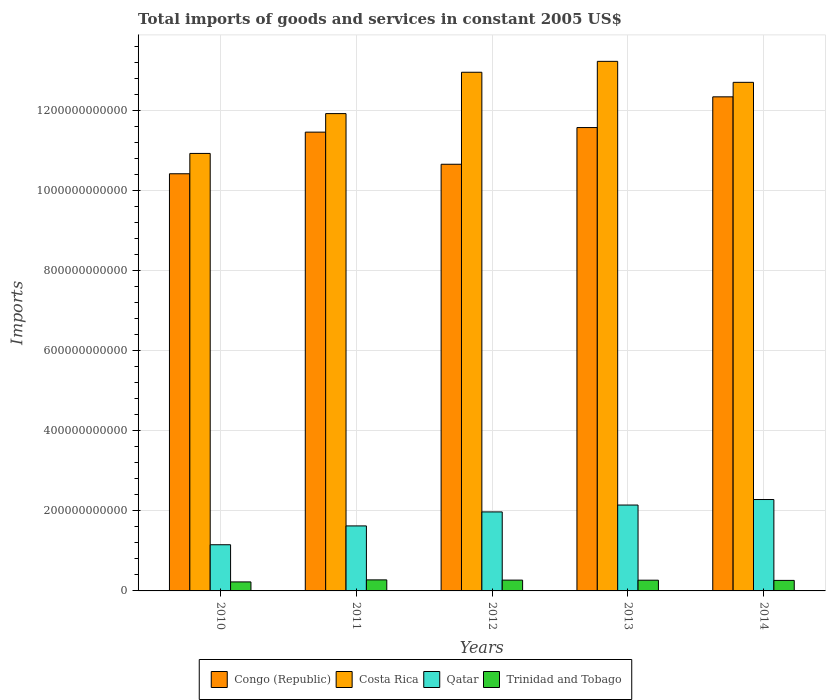How many different coloured bars are there?
Make the answer very short. 4. Are the number of bars per tick equal to the number of legend labels?
Ensure brevity in your answer.  Yes. What is the label of the 5th group of bars from the left?
Ensure brevity in your answer.  2014. What is the total imports of goods and services in Costa Rica in 2011?
Provide a succinct answer. 1.19e+12. Across all years, what is the maximum total imports of goods and services in Qatar?
Offer a terse response. 2.28e+11. Across all years, what is the minimum total imports of goods and services in Congo (Republic)?
Your answer should be compact. 1.04e+12. What is the total total imports of goods and services in Qatar in the graph?
Ensure brevity in your answer.  9.18e+11. What is the difference between the total imports of goods and services in Costa Rica in 2011 and that in 2013?
Give a very brief answer. -1.31e+11. What is the difference between the total imports of goods and services in Trinidad and Tobago in 2010 and the total imports of goods and services in Qatar in 2013?
Your response must be concise. -1.92e+11. What is the average total imports of goods and services in Trinidad and Tobago per year?
Offer a terse response. 2.60e+1. In the year 2014, what is the difference between the total imports of goods and services in Qatar and total imports of goods and services in Costa Rica?
Provide a short and direct response. -1.04e+12. In how many years, is the total imports of goods and services in Qatar greater than 80000000000 US$?
Offer a terse response. 5. What is the ratio of the total imports of goods and services in Congo (Republic) in 2010 to that in 2011?
Offer a very short reply. 0.91. What is the difference between the highest and the second highest total imports of goods and services in Congo (Republic)?
Your answer should be very brief. 7.68e+1. What is the difference between the highest and the lowest total imports of goods and services in Costa Rica?
Your answer should be compact. 2.30e+11. In how many years, is the total imports of goods and services in Costa Rica greater than the average total imports of goods and services in Costa Rica taken over all years?
Keep it short and to the point. 3. Is the sum of the total imports of goods and services in Trinidad and Tobago in 2010 and 2011 greater than the maximum total imports of goods and services in Congo (Republic) across all years?
Provide a short and direct response. No. Is it the case that in every year, the sum of the total imports of goods and services in Qatar and total imports of goods and services in Congo (Republic) is greater than the sum of total imports of goods and services in Costa Rica and total imports of goods and services in Trinidad and Tobago?
Ensure brevity in your answer.  No. What does the 1st bar from the left in 2010 represents?
Make the answer very short. Congo (Republic). What does the 3rd bar from the right in 2012 represents?
Provide a succinct answer. Costa Rica. Is it the case that in every year, the sum of the total imports of goods and services in Congo (Republic) and total imports of goods and services in Qatar is greater than the total imports of goods and services in Costa Rica?
Offer a terse response. No. How many years are there in the graph?
Your answer should be very brief. 5. What is the difference between two consecutive major ticks on the Y-axis?
Offer a very short reply. 2.00e+11. Are the values on the major ticks of Y-axis written in scientific E-notation?
Your answer should be very brief. No. Does the graph contain grids?
Your response must be concise. Yes. Where does the legend appear in the graph?
Offer a terse response. Bottom center. What is the title of the graph?
Your answer should be very brief. Total imports of goods and services in constant 2005 US$. Does "European Union" appear as one of the legend labels in the graph?
Your answer should be very brief. No. What is the label or title of the X-axis?
Provide a short and direct response. Years. What is the label or title of the Y-axis?
Make the answer very short. Imports. What is the Imports of Congo (Republic) in 2010?
Your answer should be compact. 1.04e+12. What is the Imports in Costa Rica in 2010?
Provide a succinct answer. 1.09e+12. What is the Imports in Qatar in 2010?
Offer a terse response. 1.15e+11. What is the Imports in Trinidad and Tobago in 2010?
Your answer should be very brief. 2.25e+1. What is the Imports in Congo (Republic) in 2011?
Provide a succinct answer. 1.15e+12. What is the Imports of Costa Rica in 2011?
Keep it short and to the point. 1.19e+12. What is the Imports of Qatar in 2011?
Your answer should be compact. 1.62e+11. What is the Imports of Trinidad and Tobago in 2011?
Your answer should be very brief. 2.76e+1. What is the Imports of Congo (Republic) in 2012?
Your answer should be compact. 1.07e+12. What is the Imports of Costa Rica in 2012?
Make the answer very short. 1.30e+12. What is the Imports of Qatar in 2012?
Provide a short and direct response. 1.97e+11. What is the Imports in Trinidad and Tobago in 2012?
Ensure brevity in your answer.  2.70e+1. What is the Imports in Congo (Republic) in 2013?
Your answer should be very brief. 1.16e+12. What is the Imports in Costa Rica in 2013?
Your response must be concise. 1.32e+12. What is the Imports in Qatar in 2013?
Provide a succinct answer. 2.15e+11. What is the Imports in Trinidad and Tobago in 2013?
Your response must be concise. 2.68e+1. What is the Imports in Congo (Republic) in 2014?
Offer a terse response. 1.23e+12. What is the Imports in Costa Rica in 2014?
Make the answer very short. 1.27e+12. What is the Imports in Qatar in 2014?
Keep it short and to the point. 2.28e+11. What is the Imports in Trinidad and Tobago in 2014?
Offer a very short reply. 2.63e+1. Across all years, what is the maximum Imports of Congo (Republic)?
Offer a terse response. 1.23e+12. Across all years, what is the maximum Imports in Costa Rica?
Offer a terse response. 1.32e+12. Across all years, what is the maximum Imports in Qatar?
Your response must be concise. 2.28e+11. Across all years, what is the maximum Imports in Trinidad and Tobago?
Offer a very short reply. 2.76e+1. Across all years, what is the minimum Imports of Congo (Republic)?
Give a very brief answer. 1.04e+12. Across all years, what is the minimum Imports in Costa Rica?
Your response must be concise. 1.09e+12. Across all years, what is the minimum Imports in Qatar?
Make the answer very short. 1.15e+11. Across all years, what is the minimum Imports in Trinidad and Tobago?
Offer a terse response. 2.25e+1. What is the total Imports in Congo (Republic) in the graph?
Offer a very short reply. 5.65e+12. What is the total Imports of Costa Rica in the graph?
Your answer should be very brief. 6.18e+12. What is the total Imports of Qatar in the graph?
Your answer should be compact. 9.18e+11. What is the total Imports of Trinidad and Tobago in the graph?
Your answer should be very brief. 1.30e+11. What is the difference between the Imports in Congo (Republic) in 2010 and that in 2011?
Offer a terse response. -1.04e+11. What is the difference between the Imports in Costa Rica in 2010 and that in 2011?
Offer a terse response. -9.95e+1. What is the difference between the Imports in Qatar in 2010 and that in 2011?
Provide a short and direct response. -4.71e+1. What is the difference between the Imports of Trinidad and Tobago in 2010 and that in 2011?
Provide a short and direct response. -5.08e+09. What is the difference between the Imports of Congo (Republic) in 2010 and that in 2012?
Keep it short and to the point. -2.38e+1. What is the difference between the Imports of Costa Rica in 2010 and that in 2012?
Offer a terse response. -2.03e+11. What is the difference between the Imports of Qatar in 2010 and that in 2012?
Your answer should be compact. -8.20e+1. What is the difference between the Imports in Trinidad and Tobago in 2010 and that in 2012?
Provide a short and direct response. -4.47e+09. What is the difference between the Imports in Congo (Republic) in 2010 and that in 2013?
Provide a succinct answer. -1.15e+11. What is the difference between the Imports of Costa Rica in 2010 and that in 2013?
Your response must be concise. -2.30e+11. What is the difference between the Imports in Qatar in 2010 and that in 2013?
Your answer should be compact. -9.92e+1. What is the difference between the Imports in Trinidad and Tobago in 2010 and that in 2013?
Give a very brief answer. -4.30e+09. What is the difference between the Imports of Congo (Republic) in 2010 and that in 2014?
Ensure brevity in your answer.  -1.92e+11. What is the difference between the Imports of Costa Rica in 2010 and that in 2014?
Your answer should be compact. -1.78e+11. What is the difference between the Imports in Qatar in 2010 and that in 2014?
Provide a succinct answer. -1.13e+11. What is the difference between the Imports in Trinidad and Tobago in 2010 and that in 2014?
Your answer should be very brief. -3.78e+09. What is the difference between the Imports in Congo (Republic) in 2011 and that in 2012?
Provide a succinct answer. 8.02e+1. What is the difference between the Imports in Costa Rica in 2011 and that in 2012?
Provide a succinct answer. -1.03e+11. What is the difference between the Imports of Qatar in 2011 and that in 2012?
Your response must be concise. -3.50e+1. What is the difference between the Imports of Trinidad and Tobago in 2011 and that in 2012?
Your answer should be compact. 6.05e+08. What is the difference between the Imports in Congo (Republic) in 2011 and that in 2013?
Offer a very short reply. -1.14e+1. What is the difference between the Imports of Costa Rica in 2011 and that in 2013?
Your answer should be compact. -1.31e+11. What is the difference between the Imports of Qatar in 2011 and that in 2013?
Your answer should be very brief. -5.22e+1. What is the difference between the Imports in Trinidad and Tobago in 2011 and that in 2013?
Your answer should be compact. 7.79e+08. What is the difference between the Imports of Congo (Republic) in 2011 and that in 2014?
Keep it short and to the point. -8.82e+1. What is the difference between the Imports in Costa Rica in 2011 and that in 2014?
Your answer should be very brief. -7.81e+1. What is the difference between the Imports of Qatar in 2011 and that in 2014?
Offer a terse response. -6.60e+1. What is the difference between the Imports in Trinidad and Tobago in 2011 and that in 2014?
Provide a short and direct response. 1.30e+09. What is the difference between the Imports of Congo (Republic) in 2012 and that in 2013?
Your response must be concise. -9.17e+1. What is the difference between the Imports in Costa Rica in 2012 and that in 2013?
Keep it short and to the point. -2.72e+1. What is the difference between the Imports of Qatar in 2012 and that in 2013?
Your response must be concise. -1.72e+1. What is the difference between the Imports in Trinidad and Tobago in 2012 and that in 2013?
Keep it short and to the point. 1.74e+08. What is the difference between the Imports of Congo (Republic) in 2012 and that in 2014?
Keep it short and to the point. -1.68e+11. What is the difference between the Imports of Costa Rica in 2012 and that in 2014?
Offer a very short reply. 2.52e+1. What is the difference between the Imports in Qatar in 2012 and that in 2014?
Offer a terse response. -3.10e+1. What is the difference between the Imports of Trinidad and Tobago in 2012 and that in 2014?
Your answer should be compact. 6.90e+08. What is the difference between the Imports of Congo (Republic) in 2013 and that in 2014?
Your answer should be compact. -7.68e+1. What is the difference between the Imports of Costa Rica in 2013 and that in 2014?
Provide a short and direct response. 5.24e+1. What is the difference between the Imports in Qatar in 2013 and that in 2014?
Your answer should be compact. -1.38e+1. What is the difference between the Imports of Trinidad and Tobago in 2013 and that in 2014?
Keep it short and to the point. 5.16e+08. What is the difference between the Imports in Congo (Republic) in 2010 and the Imports in Costa Rica in 2011?
Offer a terse response. -1.50e+11. What is the difference between the Imports in Congo (Republic) in 2010 and the Imports in Qatar in 2011?
Provide a succinct answer. 8.80e+11. What is the difference between the Imports in Congo (Republic) in 2010 and the Imports in Trinidad and Tobago in 2011?
Offer a very short reply. 1.01e+12. What is the difference between the Imports of Costa Rica in 2010 and the Imports of Qatar in 2011?
Keep it short and to the point. 9.31e+11. What is the difference between the Imports of Costa Rica in 2010 and the Imports of Trinidad and Tobago in 2011?
Your response must be concise. 1.07e+12. What is the difference between the Imports in Qatar in 2010 and the Imports in Trinidad and Tobago in 2011?
Give a very brief answer. 8.78e+1. What is the difference between the Imports in Congo (Republic) in 2010 and the Imports in Costa Rica in 2012?
Make the answer very short. -2.54e+11. What is the difference between the Imports of Congo (Republic) in 2010 and the Imports of Qatar in 2012?
Give a very brief answer. 8.45e+11. What is the difference between the Imports of Congo (Republic) in 2010 and the Imports of Trinidad and Tobago in 2012?
Your response must be concise. 1.02e+12. What is the difference between the Imports in Costa Rica in 2010 and the Imports in Qatar in 2012?
Provide a short and direct response. 8.96e+11. What is the difference between the Imports of Costa Rica in 2010 and the Imports of Trinidad and Tobago in 2012?
Keep it short and to the point. 1.07e+12. What is the difference between the Imports in Qatar in 2010 and the Imports in Trinidad and Tobago in 2012?
Offer a very short reply. 8.84e+1. What is the difference between the Imports of Congo (Republic) in 2010 and the Imports of Costa Rica in 2013?
Ensure brevity in your answer.  -2.81e+11. What is the difference between the Imports of Congo (Republic) in 2010 and the Imports of Qatar in 2013?
Offer a terse response. 8.28e+11. What is the difference between the Imports of Congo (Republic) in 2010 and the Imports of Trinidad and Tobago in 2013?
Your response must be concise. 1.02e+12. What is the difference between the Imports of Costa Rica in 2010 and the Imports of Qatar in 2013?
Offer a very short reply. 8.79e+11. What is the difference between the Imports in Costa Rica in 2010 and the Imports in Trinidad and Tobago in 2013?
Offer a terse response. 1.07e+12. What is the difference between the Imports in Qatar in 2010 and the Imports in Trinidad and Tobago in 2013?
Your answer should be very brief. 8.86e+1. What is the difference between the Imports of Congo (Republic) in 2010 and the Imports of Costa Rica in 2014?
Your response must be concise. -2.28e+11. What is the difference between the Imports of Congo (Republic) in 2010 and the Imports of Qatar in 2014?
Offer a terse response. 8.14e+11. What is the difference between the Imports in Congo (Republic) in 2010 and the Imports in Trinidad and Tobago in 2014?
Ensure brevity in your answer.  1.02e+12. What is the difference between the Imports in Costa Rica in 2010 and the Imports in Qatar in 2014?
Give a very brief answer. 8.65e+11. What is the difference between the Imports of Costa Rica in 2010 and the Imports of Trinidad and Tobago in 2014?
Your response must be concise. 1.07e+12. What is the difference between the Imports of Qatar in 2010 and the Imports of Trinidad and Tobago in 2014?
Ensure brevity in your answer.  8.91e+1. What is the difference between the Imports in Congo (Republic) in 2011 and the Imports in Costa Rica in 2012?
Provide a short and direct response. -1.50e+11. What is the difference between the Imports in Congo (Republic) in 2011 and the Imports in Qatar in 2012?
Offer a very short reply. 9.49e+11. What is the difference between the Imports in Congo (Republic) in 2011 and the Imports in Trinidad and Tobago in 2012?
Offer a very short reply. 1.12e+12. What is the difference between the Imports in Costa Rica in 2011 and the Imports in Qatar in 2012?
Make the answer very short. 9.95e+11. What is the difference between the Imports in Costa Rica in 2011 and the Imports in Trinidad and Tobago in 2012?
Offer a very short reply. 1.17e+12. What is the difference between the Imports in Qatar in 2011 and the Imports in Trinidad and Tobago in 2012?
Ensure brevity in your answer.  1.35e+11. What is the difference between the Imports of Congo (Republic) in 2011 and the Imports of Costa Rica in 2013?
Ensure brevity in your answer.  -1.77e+11. What is the difference between the Imports of Congo (Republic) in 2011 and the Imports of Qatar in 2013?
Offer a very short reply. 9.32e+11. What is the difference between the Imports in Congo (Republic) in 2011 and the Imports in Trinidad and Tobago in 2013?
Your response must be concise. 1.12e+12. What is the difference between the Imports of Costa Rica in 2011 and the Imports of Qatar in 2013?
Ensure brevity in your answer.  9.78e+11. What is the difference between the Imports in Costa Rica in 2011 and the Imports in Trinidad and Tobago in 2013?
Provide a short and direct response. 1.17e+12. What is the difference between the Imports in Qatar in 2011 and the Imports in Trinidad and Tobago in 2013?
Offer a terse response. 1.36e+11. What is the difference between the Imports of Congo (Republic) in 2011 and the Imports of Costa Rica in 2014?
Keep it short and to the point. -1.24e+11. What is the difference between the Imports of Congo (Republic) in 2011 and the Imports of Qatar in 2014?
Offer a very short reply. 9.18e+11. What is the difference between the Imports in Congo (Republic) in 2011 and the Imports in Trinidad and Tobago in 2014?
Offer a very short reply. 1.12e+12. What is the difference between the Imports of Costa Rica in 2011 and the Imports of Qatar in 2014?
Give a very brief answer. 9.64e+11. What is the difference between the Imports of Costa Rica in 2011 and the Imports of Trinidad and Tobago in 2014?
Offer a terse response. 1.17e+12. What is the difference between the Imports in Qatar in 2011 and the Imports in Trinidad and Tobago in 2014?
Your answer should be very brief. 1.36e+11. What is the difference between the Imports in Congo (Republic) in 2012 and the Imports in Costa Rica in 2013?
Ensure brevity in your answer.  -2.57e+11. What is the difference between the Imports in Congo (Republic) in 2012 and the Imports in Qatar in 2013?
Provide a short and direct response. 8.52e+11. What is the difference between the Imports in Congo (Republic) in 2012 and the Imports in Trinidad and Tobago in 2013?
Ensure brevity in your answer.  1.04e+12. What is the difference between the Imports of Costa Rica in 2012 and the Imports of Qatar in 2013?
Make the answer very short. 1.08e+12. What is the difference between the Imports in Costa Rica in 2012 and the Imports in Trinidad and Tobago in 2013?
Provide a short and direct response. 1.27e+12. What is the difference between the Imports of Qatar in 2012 and the Imports of Trinidad and Tobago in 2013?
Provide a succinct answer. 1.71e+11. What is the difference between the Imports of Congo (Republic) in 2012 and the Imports of Costa Rica in 2014?
Provide a short and direct response. -2.05e+11. What is the difference between the Imports in Congo (Republic) in 2012 and the Imports in Qatar in 2014?
Provide a short and direct response. 8.38e+11. What is the difference between the Imports of Congo (Republic) in 2012 and the Imports of Trinidad and Tobago in 2014?
Your answer should be very brief. 1.04e+12. What is the difference between the Imports in Costa Rica in 2012 and the Imports in Qatar in 2014?
Keep it short and to the point. 1.07e+12. What is the difference between the Imports of Costa Rica in 2012 and the Imports of Trinidad and Tobago in 2014?
Your response must be concise. 1.27e+12. What is the difference between the Imports in Qatar in 2012 and the Imports in Trinidad and Tobago in 2014?
Provide a succinct answer. 1.71e+11. What is the difference between the Imports of Congo (Republic) in 2013 and the Imports of Costa Rica in 2014?
Offer a very short reply. -1.13e+11. What is the difference between the Imports of Congo (Republic) in 2013 and the Imports of Qatar in 2014?
Give a very brief answer. 9.29e+11. What is the difference between the Imports in Congo (Republic) in 2013 and the Imports in Trinidad and Tobago in 2014?
Keep it short and to the point. 1.13e+12. What is the difference between the Imports in Costa Rica in 2013 and the Imports in Qatar in 2014?
Offer a terse response. 1.09e+12. What is the difference between the Imports of Costa Rica in 2013 and the Imports of Trinidad and Tobago in 2014?
Make the answer very short. 1.30e+12. What is the difference between the Imports of Qatar in 2013 and the Imports of Trinidad and Tobago in 2014?
Your answer should be compact. 1.88e+11. What is the average Imports in Congo (Republic) per year?
Offer a terse response. 1.13e+12. What is the average Imports of Costa Rica per year?
Offer a very short reply. 1.24e+12. What is the average Imports in Qatar per year?
Your answer should be very brief. 1.84e+11. What is the average Imports in Trinidad and Tobago per year?
Provide a short and direct response. 2.60e+1. In the year 2010, what is the difference between the Imports of Congo (Republic) and Imports of Costa Rica?
Your answer should be very brief. -5.08e+1. In the year 2010, what is the difference between the Imports of Congo (Republic) and Imports of Qatar?
Your answer should be very brief. 9.27e+11. In the year 2010, what is the difference between the Imports of Congo (Republic) and Imports of Trinidad and Tobago?
Your answer should be very brief. 1.02e+12. In the year 2010, what is the difference between the Imports in Costa Rica and Imports in Qatar?
Provide a succinct answer. 9.78e+11. In the year 2010, what is the difference between the Imports in Costa Rica and Imports in Trinidad and Tobago?
Your answer should be compact. 1.07e+12. In the year 2010, what is the difference between the Imports in Qatar and Imports in Trinidad and Tobago?
Your answer should be compact. 9.29e+1. In the year 2011, what is the difference between the Imports in Congo (Republic) and Imports in Costa Rica?
Give a very brief answer. -4.63e+1. In the year 2011, what is the difference between the Imports of Congo (Republic) and Imports of Qatar?
Your answer should be very brief. 9.84e+11. In the year 2011, what is the difference between the Imports in Congo (Republic) and Imports in Trinidad and Tobago?
Offer a terse response. 1.12e+12. In the year 2011, what is the difference between the Imports of Costa Rica and Imports of Qatar?
Your answer should be very brief. 1.03e+12. In the year 2011, what is the difference between the Imports of Costa Rica and Imports of Trinidad and Tobago?
Give a very brief answer. 1.17e+12. In the year 2011, what is the difference between the Imports in Qatar and Imports in Trinidad and Tobago?
Make the answer very short. 1.35e+11. In the year 2012, what is the difference between the Imports of Congo (Republic) and Imports of Costa Rica?
Give a very brief answer. -2.30e+11. In the year 2012, what is the difference between the Imports in Congo (Republic) and Imports in Qatar?
Provide a short and direct response. 8.69e+11. In the year 2012, what is the difference between the Imports in Congo (Republic) and Imports in Trinidad and Tobago?
Offer a very short reply. 1.04e+12. In the year 2012, what is the difference between the Imports of Costa Rica and Imports of Qatar?
Give a very brief answer. 1.10e+12. In the year 2012, what is the difference between the Imports in Costa Rica and Imports in Trinidad and Tobago?
Offer a terse response. 1.27e+12. In the year 2012, what is the difference between the Imports of Qatar and Imports of Trinidad and Tobago?
Keep it short and to the point. 1.70e+11. In the year 2013, what is the difference between the Imports of Congo (Republic) and Imports of Costa Rica?
Your answer should be very brief. -1.65e+11. In the year 2013, what is the difference between the Imports in Congo (Republic) and Imports in Qatar?
Offer a terse response. 9.43e+11. In the year 2013, what is the difference between the Imports of Congo (Republic) and Imports of Trinidad and Tobago?
Your answer should be compact. 1.13e+12. In the year 2013, what is the difference between the Imports of Costa Rica and Imports of Qatar?
Your answer should be compact. 1.11e+12. In the year 2013, what is the difference between the Imports of Costa Rica and Imports of Trinidad and Tobago?
Keep it short and to the point. 1.30e+12. In the year 2013, what is the difference between the Imports of Qatar and Imports of Trinidad and Tobago?
Offer a very short reply. 1.88e+11. In the year 2014, what is the difference between the Imports in Congo (Republic) and Imports in Costa Rica?
Ensure brevity in your answer.  -3.62e+1. In the year 2014, what is the difference between the Imports in Congo (Republic) and Imports in Qatar?
Keep it short and to the point. 1.01e+12. In the year 2014, what is the difference between the Imports of Congo (Republic) and Imports of Trinidad and Tobago?
Your response must be concise. 1.21e+12. In the year 2014, what is the difference between the Imports in Costa Rica and Imports in Qatar?
Provide a short and direct response. 1.04e+12. In the year 2014, what is the difference between the Imports in Costa Rica and Imports in Trinidad and Tobago?
Your answer should be compact. 1.24e+12. In the year 2014, what is the difference between the Imports in Qatar and Imports in Trinidad and Tobago?
Make the answer very short. 2.02e+11. What is the ratio of the Imports of Congo (Republic) in 2010 to that in 2011?
Your response must be concise. 0.91. What is the ratio of the Imports in Costa Rica in 2010 to that in 2011?
Offer a terse response. 0.92. What is the ratio of the Imports in Qatar in 2010 to that in 2011?
Your response must be concise. 0.71. What is the ratio of the Imports of Trinidad and Tobago in 2010 to that in 2011?
Offer a terse response. 0.82. What is the ratio of the Imports of Congo (Republic) in 2010 to that in 2012?
Give a very brief answer. 0.98. What is the ratio of the Imports of Costa Rica in 2010 to that in 2012?
Keep it short and to the point. 0.84. What is the ratio of the Imports of Qatar in 2010 to that in 2012?
Ensure brevity in your answer.  0.58. What is the ratio of the Imports of Trinidad and Tobago in 2010 to that in 2012?
Keep it short and to the point. 0.83. What is the ratio of the Imports of Congo (Republic) in 2010 to that in 2013?
Make the answer very short. 0.9. What is the ratio of the Imports of Costa Rica in 2010 to that in 2013?
Offer a very short reply. 0.83. What is the ratio of the Imports in Qatar in 2010 to that in 2013?
Your answer should be compact. 0.54. What is the ratio of the Imports in Trinidad and Tobago in 2010 to that in 2013?
Keep it short and to the point. 0.84. What is the ratio of the Imports of Congo (Republic) in 2010 to that in 2014?
Your answer should be very brief. 0.84. What is the ratio of the Imports of Costa Rica in 2010 to that in 2014?
Keep it short and to the point. 0.86. What is the ratio of the Imports in Qatar in 2010 to that in 2014?
Provide a short and direct response. 0.51. What is the ratio of the Imports of Trinidad and Tobago in 2010 to that in 2014?
Give a very brief answer. 0.86. What is the ratio of the Imports of Congo (Republic) in 2011 to that in 2012?
Keep it short and to the point. 1.08. What is the ratio of the Imports in Costa Rica in 2011 to that in 2012?
Provide a succinct answer. 0.92. What is the ratio of the Imports in Qatar in 2011 to that in 2012?
Make the answer very short. 0.82. What is the ratio of the Imports of Trinidad and Tobago in 2011 to that in 2012?
Ensure brevity in your answer.  1.02. What is the ratio of the Imports of Costa Rica in 2011 to that in 2013?
Your answer should be very brief. 0.9. What is the ratio of the Imports of Qatar in 2011 to that in 2013?
Offer a terse response. 0.76. What is the ratio of the Imports in Trinidad and Tobago in 2011 to that in 2013?
Your response must be concise. 1.03. What is the ratio of the Imports in Costa Rica in 2011 to that in 2014?
Ensure brevity in your answer.  0.94. What is the ratio of the Imports of Qatar in 2011 to that in 2014?
Make the answer very short. 0.71. What is the ratio of the Imports in Trinidad and Tobago in 2011 to that in 2014?
Ensure brevity in your answer.  1.05. What is the ratio of the Imports of Congo (Republic) in 2012 to that in 2013?
Your response must be concise. 0.92. What is the ratio of the Imports in Costa Rica in 2012 to that in 2013?
Ensure brevity in your answer.  0.98. What is the ratio of the Imports of Qatar in 2012 to that in 2013?
Your response must be concise. 0.92. What is the ratio of the Imports of Trinidad and Tobago in 2012 to that in 2013?
Your response must be concise. 1.01. What is the ratio of the Imports of Congo (Republic) in 2012 to that in 2014?
Make the answer very short. 0.86. What is the ratio of the Imports in Costa Rica in 2012 to that in 2014?
Ensure brevity in your answer.  1.02. What is the ratio of the Imports of Qatar in 2012 to that in 2014?
Ensure brevity in your answer.  0.86. What is the ratio of the Imports in Trinidad and Tobago in 2012 to that in 2014?
Offer a terse response. 1.03. What is the ratio of the Imports of Congo (Republic) in 2013 to that in 2014?
Your answer should be very brief. 0.94. What is the ratio of the Imports in Costa Rica in 2013 to that in 2014?
Provide a short and direct response. 1.04. What is the ratio of the Imports in Qatar in 2013 to that in 2014?
Your answer should be compact. 0.94. What is the ratio of the Imports in Trinidad and Tobago in 2013 to that in 2014?
Offer a terse response. 1.02. What is the difference between the highest and the second highest Imports in Congo (Republic)?
Your answer should be compact. 7.68e+1. What is the difference between the highest and the second highest Imports of Costa Rica?
Your answer should be compact. 2.72e+1. What is the difference between the highest and the second highest Imports of Qatar?
Offer a terse response. 1.38e+1. What is the difference between the highest and the second highest Imports in Trinidad and Tobago?
Offer a very short reply. 6.05e+08. What is the difference between the highest and the lowest Imports in Congo (Republic)?
Make the answer very short. 1.92e+11. What is the difference between the highest and the lowest Imports in Costa Rica?
Give a very brief answer. 2.30e+11. What is the difference between the highest and the lowest Imports in Qatar?
Offer a very short reply. 1.13e+11. What is the difference between the highest and the lowest Imports of Trinidad and Tobago?
Your response must be concise. 5.08e+09. 